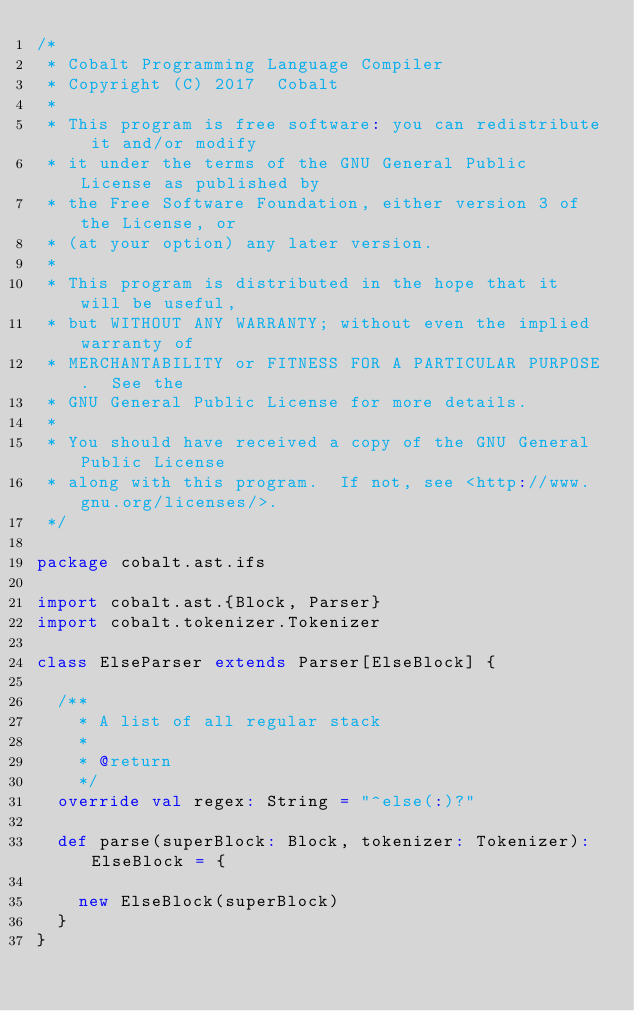Convert code to text. <code><loc_0><loc_0><loc_500><loc_500><_Scala_>/*
 * Cobalt Programming Language Compiler
 * Copyright (C) 2017  Cobalt
 *
 * This program is free software: you can redistribute it and/or modify
 * it under the terms of the GNU General Public License as published by
 * the Free Software Foundation, either version 3 of the License, or
 * (at your option) any later version.
 *
 * This program is distributed in the hope that it will be useful,
 * but WITHOUT ANY WARRANTY; without even the implied warranty of
 * MERCHANTABILITY or FITNESS FOR A PARTICULAR PURPOSE.  See the
 * GNU General Public License for more details.
 *
 * You should have received a copy of the GNU General Public License
 * along with this program.  If not, see <http://www.gnu.org/licenses/>.
 */

package cobalt.ast.ifs

import cobalt.ast.{Block, Parser}
import cobalt.tokenizer.Tokenizer

class ElseParser extends Parser[ElseBlock] {

  /**
    * A list of all regular stack
    *
    * @return
    */
  override val regex: String = "^else(:)?"

  def parse(superBlock: Block, tokenizer: Tokenizer): ElseBlock = {

    new ElseBlock(superBlock)
  }
}
</code> 